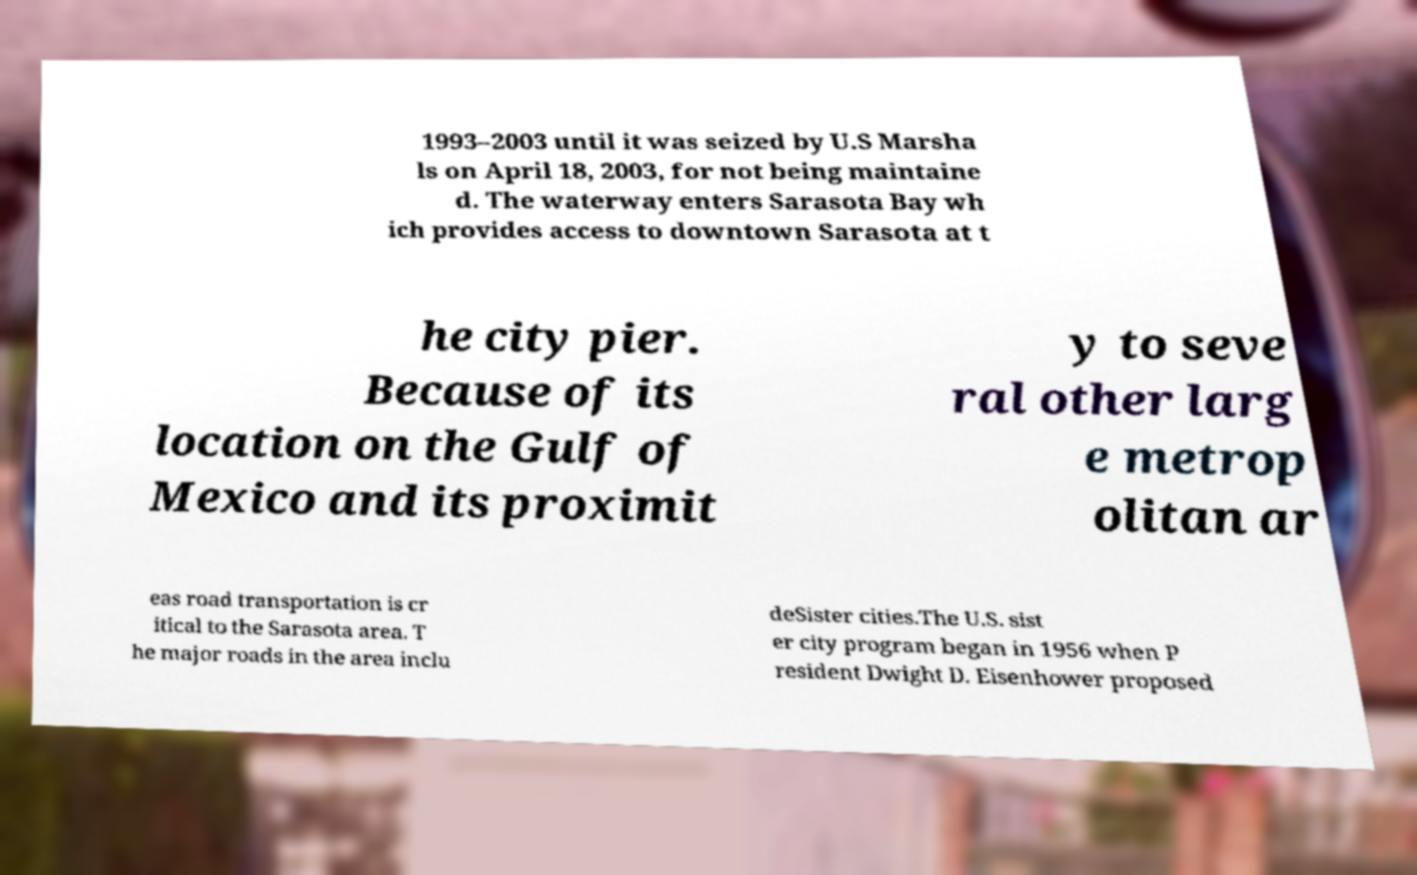Could you extract and type out the text from this image? 1993–2003 until it was seized by U.S Marsha ls on April 18, 2003, for not being maintaine d. The waterway enters Sarasota Bay wh ich provides access to downtown Sarasota at t he city pier. Because of its location on the Gulf of Mexico and its proximit y to seve ral other larg e metrop olitan ar eas road transportation is cr itical to the Sarasota area. T he major roads in the area inclu deSister cities.The U.S. sist er city program began in 1956 when P resident Dwight D. Eisenhower proposed 